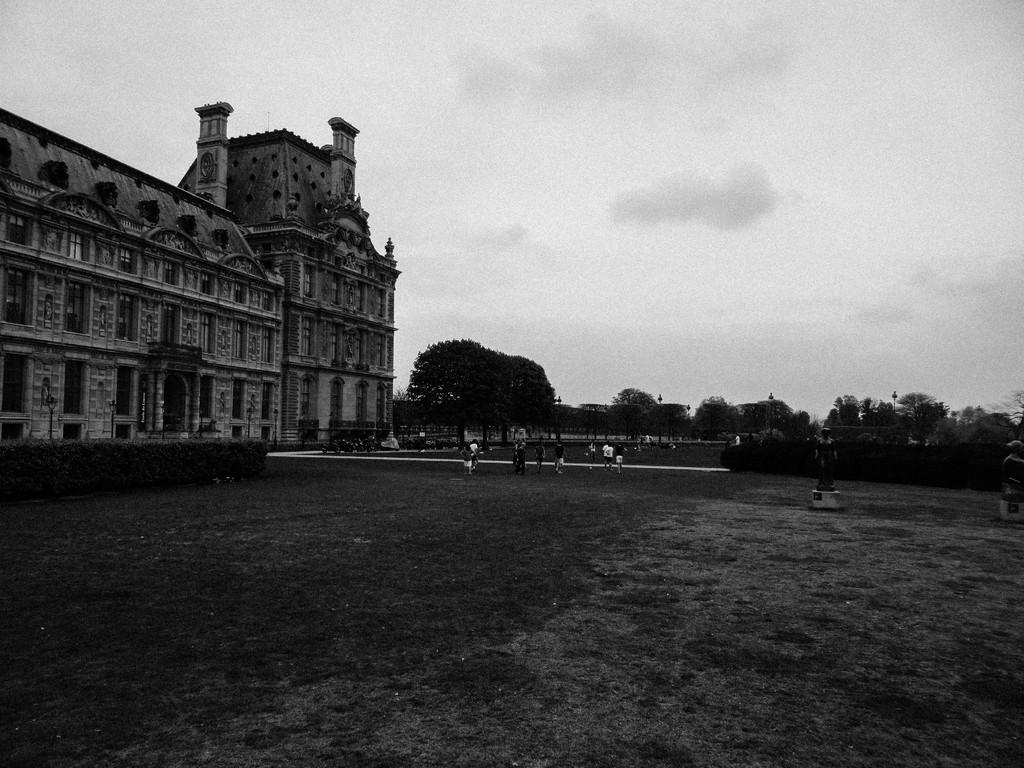What is the color scheme of the image? The image is black and white. What structure can be seen on the left side of the image? There is a building on the left side of the image. What type of vegetation is present in front of the building? Trees are present in front of the building on a grassland. What is visible in the background of the image? The sky is visible in the image. What can be observed in the sky? Clouds are present in the sky. What type of attraction is present in the image? There is no attraction mentioned or visible in the image. What type of fuel is being used by the machine in the image? There is no machine present in the image. 